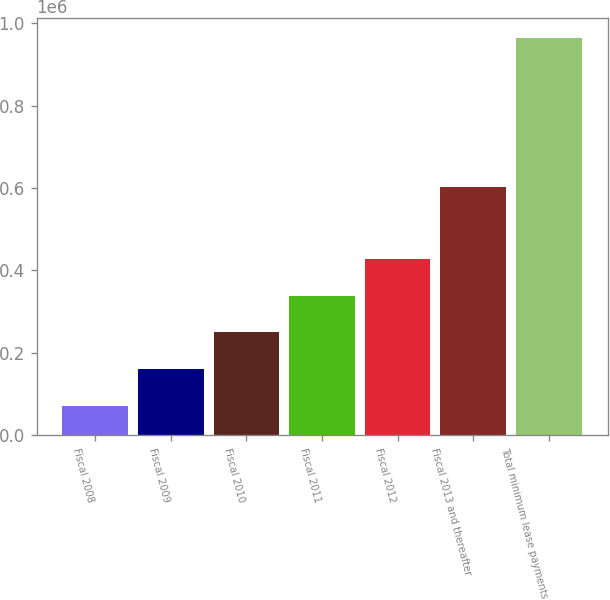<chart> <loc_0><loc_0><loc_500><loc_500><bar_chart><fcel>Fiscal 2008<fcel>Fiscal 2009<fcel>Fiscal 2010<fcel>Fiscal 2011<fcel>Fiscal 2012<fcel>Fiscal 2013 and thereafter<fcel>Total minimum lease payments<nl><fcel>71041<fcel>160309<fcel>249578<fcel>338846<fcel>428115<fcel>602955<fcel>963725<nl></chart> 